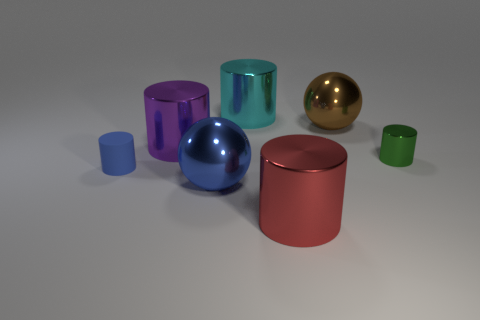Is there a big sphere that has the same color as the rubber thing?
Give a very brief answer. Yes. What shape is the thing that is both left of the blue metallic object and on the right side of the matte thing?
Provide a succinct answer. Cylinder. What number of big cyan cylinders are the same material as the purple cylinder?
Your answer should be very brief. 1. Is the number of big cyan cylinders that are to the left of the brown metallic thing less than the number of blue metal things right of the big blue sphere?
Make the answer very short. No. The sphere that is behind the large shiny ball in front of the small cylinder to the right of the big purple object is made of what material?
Ensure brevity in your answer.  Metal. There is a metallic cylinder that is both in front of the big purple object and behind the blue cylinder; how big is it?
Make the answer very short. Small. What number of blocks are either big cyan metallic objects or tiny blue rubber objects?
Your answer should be compact. 0. There is another cylinder that is the same size as the blue cylinder; what color is it?
Ensure brevity in your answer.  Green. Is there anything else that has the same shape as the tiny blue object?
Make the answer very short. Yes. There is a small shiny thing that is the same shape as the blue matte object; what is its color?
Your response must be concise. Green. 